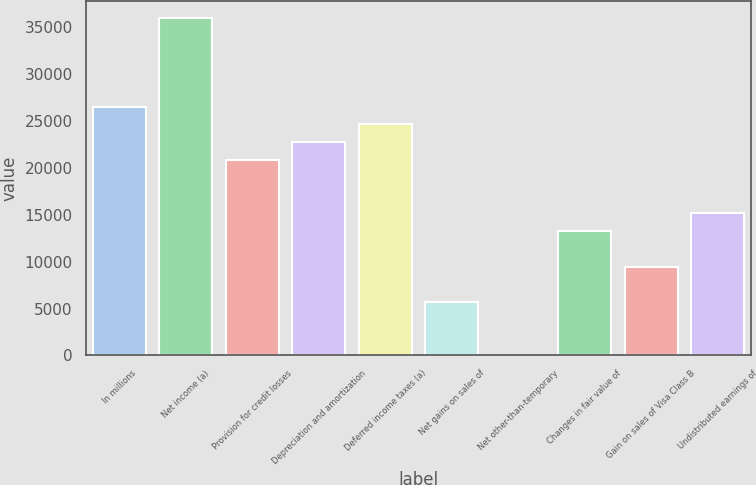Convert chart. <chart><loc_0><loc_0><loc_500><loc_500><bar_chart><fcel>In millions<fcel>Net income (a)<fcel>Provision for credit losses<fcel>Depreciation and amortization<fcel>Deferred income taxes (a)<fcel>Net gains on sales of<fcel>Net other-than-temporary<fcel>Changes in fair value of<fcel>Gain on sales of Visa Class B<fcel>Undistributed earnings of<nl><fcel>26502.6<fcel>35962.1<fcel>20826.9<fcel>22718.8<fcel>24610.7<fcel>5691.7<fcel>16<fcel>13259.3<fcel>9475.5<fcel>15151.2<nl></chart> 